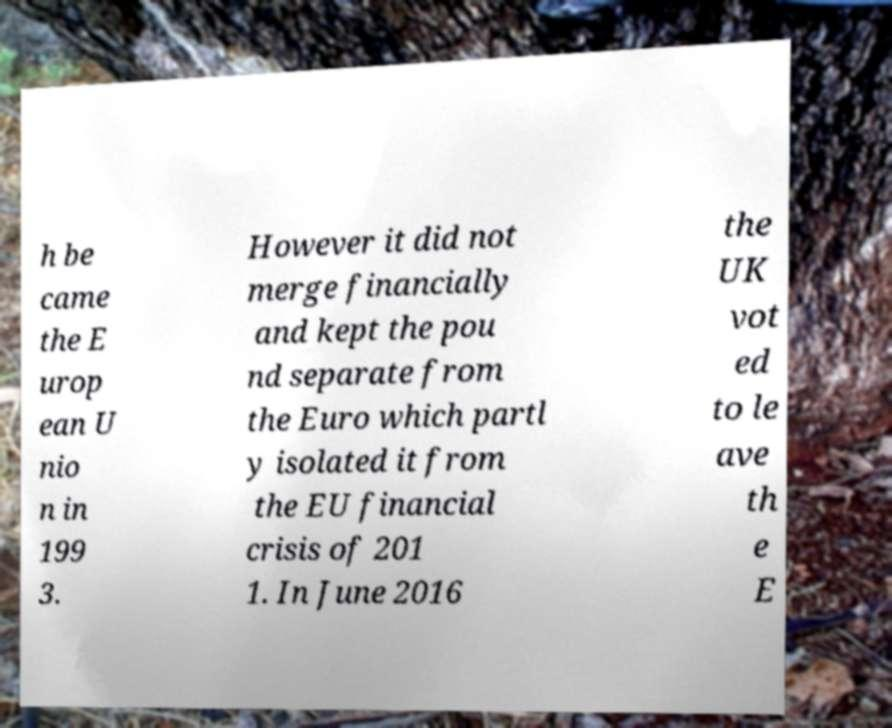I need the written content from this picture converted into text. Can you do that? h be came the E urop ean U nio n in 199 3. However it did not merge financially and kept the pou nd separate from the Euro which partl y isolated it from the EU financial crisis of 201 1. In June 2016 the UK vot ed to le ave th e E 